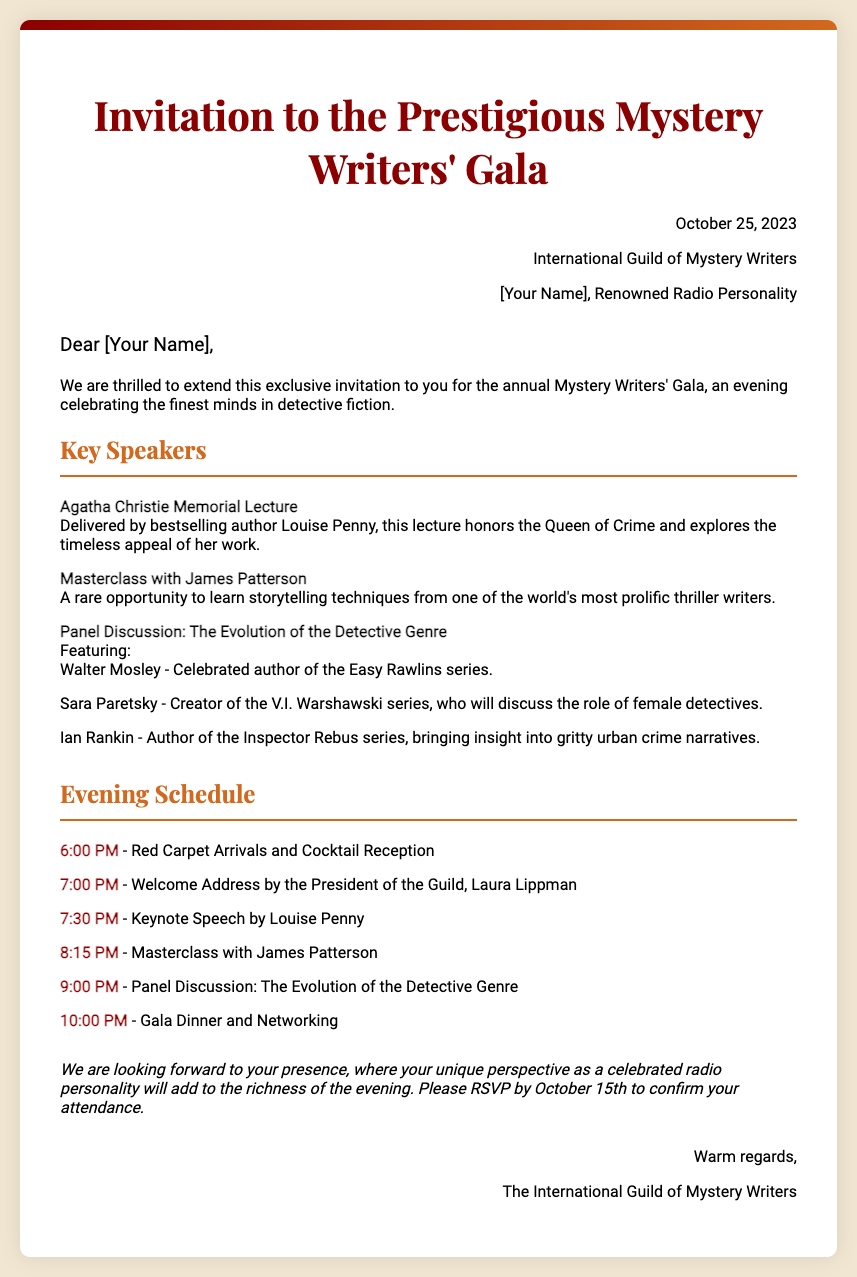What is the date of the gala? The date of the gala is mentioned at the beginning of the document as October 25, 2023.
Answer: October 25, 2023 Who is delivering the Agatha Christie Memorial Lecture? The document specifies that the lecture is delivered by bestselling author Louise Penny.
Answer: Louise Penny What time does the cocktail reception start? The schedule lists the cocktail reception starting at 6:00 PM.
Answer: 6:00 PM Which author is hosting a masterclass? The document indicates that James Patterson is hosting the masterclass.
Answer: James Patterson What is the main theme of the panel discussion? The panel discussion focuses on "The Evolution of the Detective Genre," as clearly stated in the document.
Answer: The Evolution of the Detective Genre How many speakers are listed for the panel discussion? The document lists three speakers for the panel discussion.
Answer: Three By what date should attendees RSVP? The document asks attendees to RSVP by October 15th.
Answer: October 15th Who will give the welcome address? The document states that the welcome address will be given by Laura Lippman.
Answer: Laura Lippman What is the closing remark style in the invitation? The closing remark of the invitation is noted as italicized, suggesting a formal tone.
Answer: Italic 